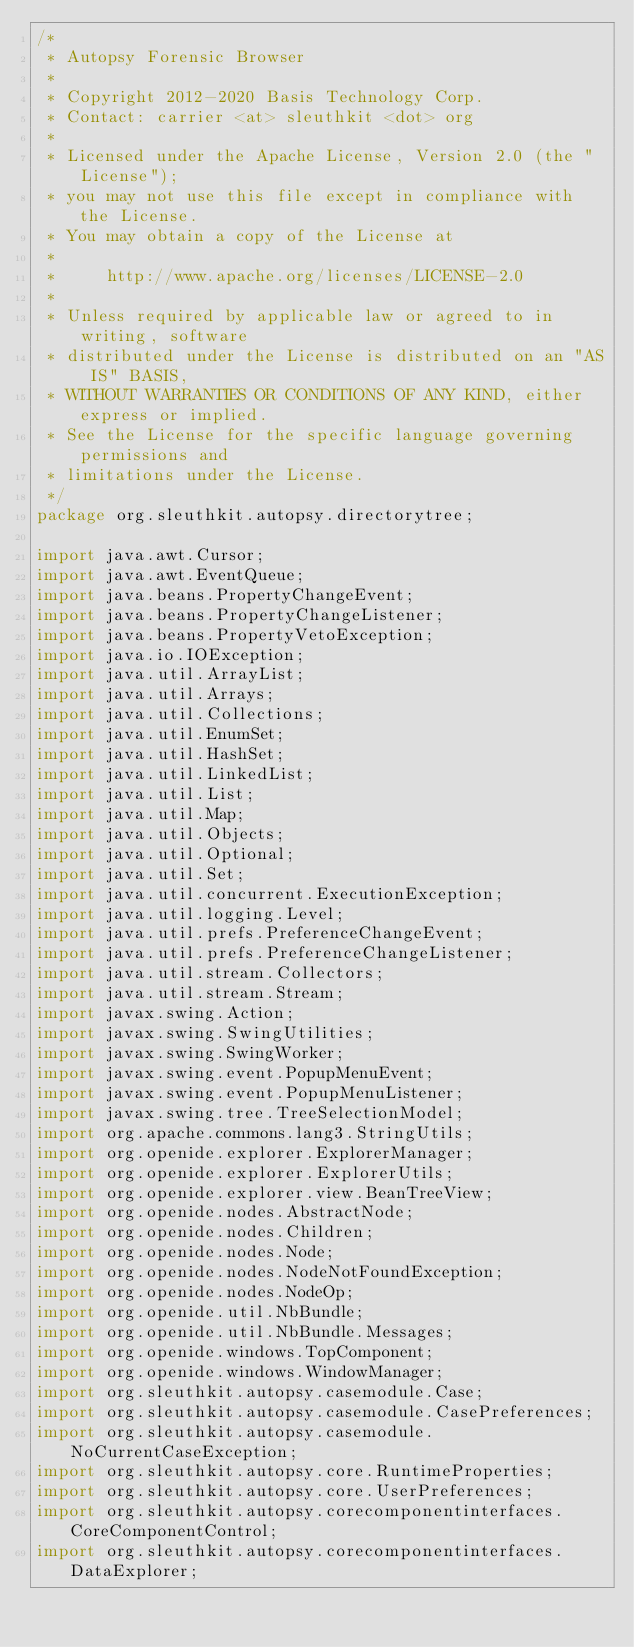Convert code to text. <code><loc_0><loc_0><loc_500><loc_500><_Java_>/*
 * Autopsy Forensic Browser
 *
 * Copyright 2012-2020 Basis Technology Corp.
 * Contact: carrier <at> sleuthkit <dot> org
 *
 * Licensed under the Apache License, Version 2.0 (the "License");
 * you may not use this file except in compliance with the License.
 * You may obtain a copy of the License at
 *
 *     http://www.apache.org/licenses/LICENSE-2.0
 *
 * Unless required by applicable law or agreed to in writing, software
 * distributed under the License is distributed on an "AS IS" BASIS,
 * WITHOUT WARRANTIES OR CONDITIONS OF ANY KIND, either express or implied.
 * See the License for the specific language governing permissions and
 * limitations under the License.
 */
package org.sleuthkit.autopsy.directorytree;

import java.awt.Cursor;
import java.awt.EventQueue;
import java.beans.PropertyChangeEvent;
import java.beans.PropertyChangeListener;
import java.beans.PropertyVetoException;
import java.io.IOException;
import java.util.ArrayList;
import java.util.Arrays;
import java.util.Collections;
import java.util.EnumSet;
import java.util.HashSet;
import java.util.LinkedList;
import java.util.List;
import java.util.Map;
import java.util.Objects;
import java.util.Optional;
import java.util.Set;
import java.util.concurrent.ExecutionException;
import java.util.logging.Level;
import java.util.prefs.PreferenceChangeEvent;
import java.util.prefs.PreferenceChangeListener;
import java.util.stream.Collectors;
import java.util.stream.Stream;
import javax.swing.Action;
import javax.swing.SwingUtilities;
import javax.swing.SwingWorker;
import javax.swing.event.PopupMenuEvent;
import javax.swing.event.PopupMenuListener;
import javax.swing.tree.TreeSelectionModel;
import org.apache.commons.lang3.StringUtils;
import org.openide.explorer.ExplorerManager;
import org.openide.explorer.ExplorerUtils;
import org.openide.explorer.view.BeanTreeView;
import org.openide.nodes.AbstractNode;
import org.openide.nodes.Children;
import org.openide.nodes.Node;
import org.openide.nodes.NodeNotFoundException;
import org.openide.nodes.NodeOp;
import org.openide.util.NbBundle;
import org.openide.util.NbBundle.Messages;
import org.openide.windows.TopComponent;
import org.openide.windows.WindowManager;
import org.sleuthkit.autopsy.casemodule.Case;
import org.sleuthkit.autopsy.casemodule.CasePreferences;
import org.sleuthkit.autopsy.casemodule.NoCurrentCaseException;
import org.sleuthkit.autopsy.core.RuntimeProperties;
import org.sleuthkit.autopsy.core.UserPreferences;
import org.sleuthkit.autopsy.corecomponentinterfaces.CoreComponentControl;
import org.sleuthkit.autopsy.corecomponentinterfaces.DataExplorer;</code> 